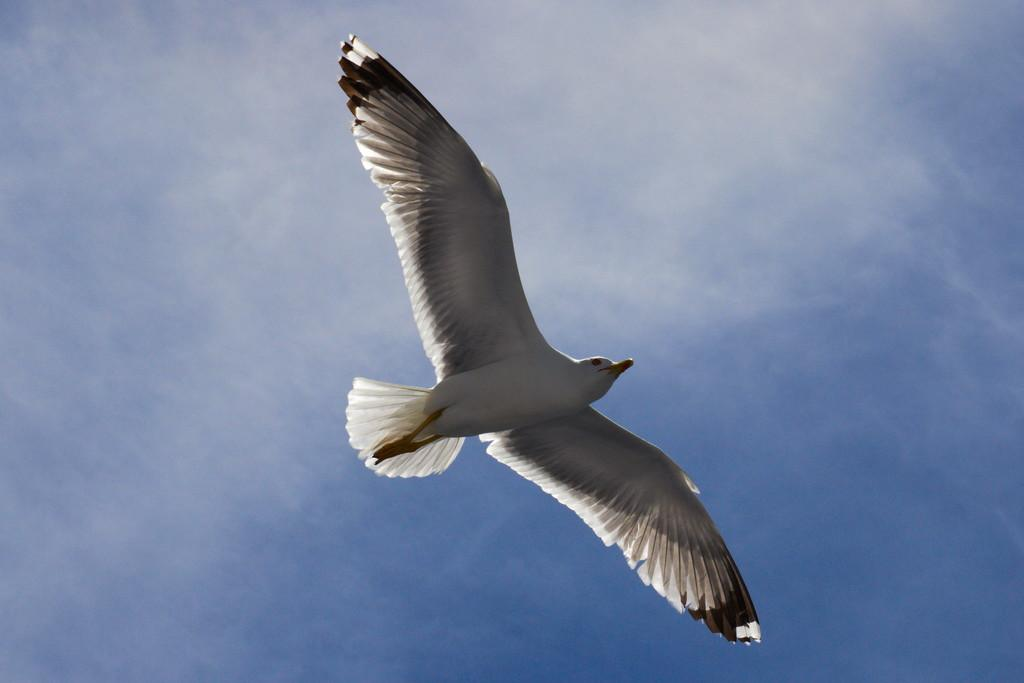What type of animal can be seen in the image? There is a bird in the image. What is the bird doing in the image? The bird is flying in the air. What shape is the steam coming from the bird's beak in the image? There is no steam coming from the bird's beak in the image, as birds do not produce steam. 